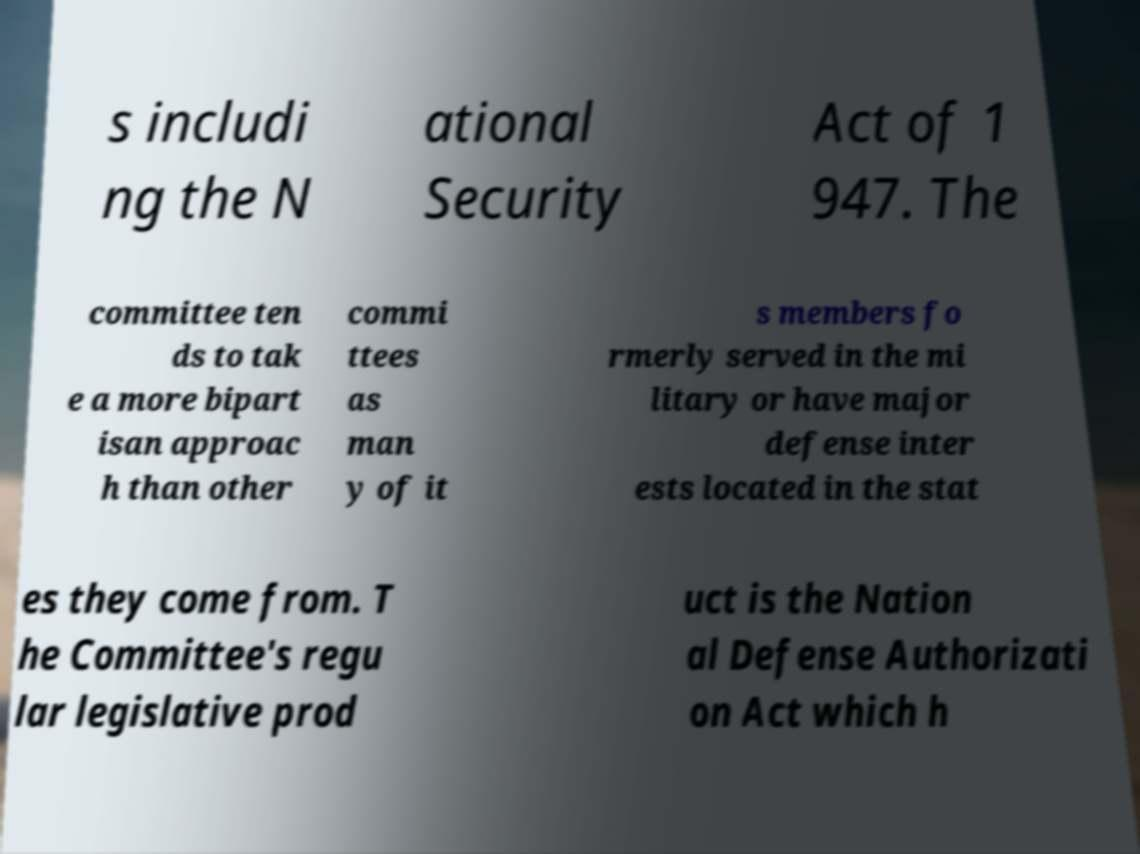What messages or text are displayed in this image? I need them in a readable, typed format. s includi ng the N ational Security Act of 1 947. The committee ten ds to tak e a more bipart isan approac h than other commi ttees as man y of it s members fo rmerly served in the mi litary or have major defense inter ests located in the stat es they come from. T he Committee's regu lar legislative prod uct is the Nation al Defense Authorizati on Act which h 